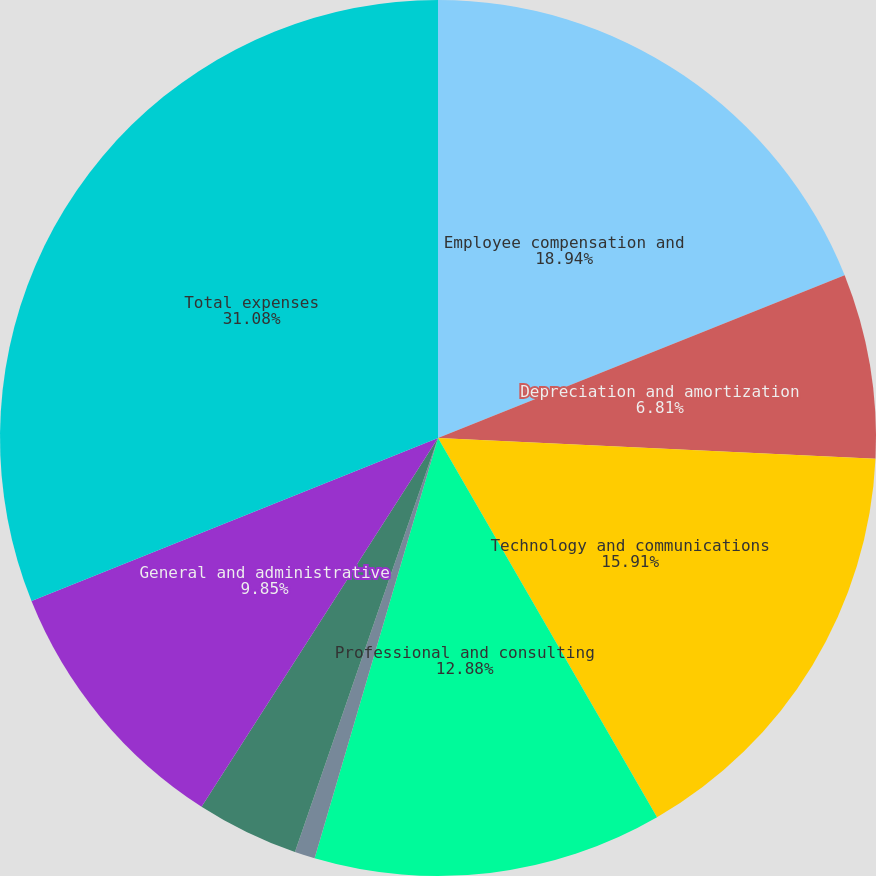Convert chart. <chart><loc_0><loc_0><loc_500><loc_500><pie_chart><fcel>Employee compensation and<fcel>Depreciation and amortization<fcel>Technology and communications<fcel>Professional and consulting<fcel>Occupancy<fcel>Marketing and advertising<fcel>General and administrative<fcel>Total expenses<nl><fcel>18.94%<fcel>6.81%<fcel>15.91%<fcel>12.88%<fcel>0.75%<fcel>3.78%<fcel>9.85%<fcel>31.07%<nl></chart> 